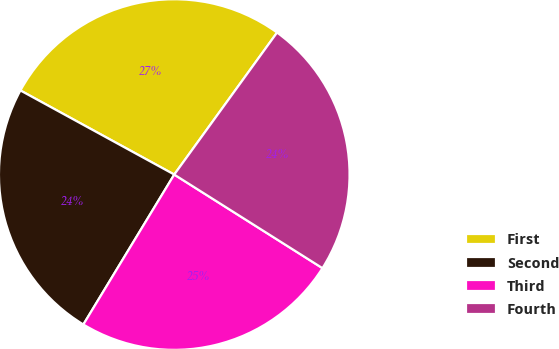Convert chart to OTSL. <chart><loc_0><loc_0><loc_500><loc_500><pie_chart><fcel>First<fcel>Second<fcel>Third<fcel>Fourth<nl><fcel>27.01%<fcel>24.29%<fcel>24.71%<fcel>23.99%<nl></chart> 